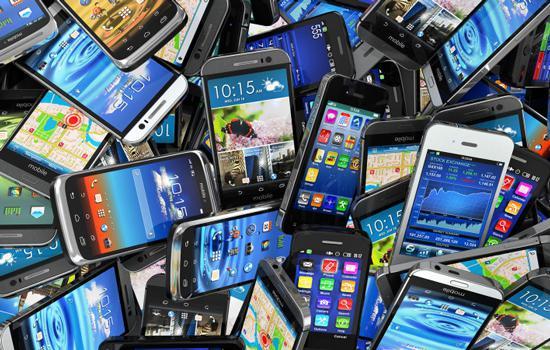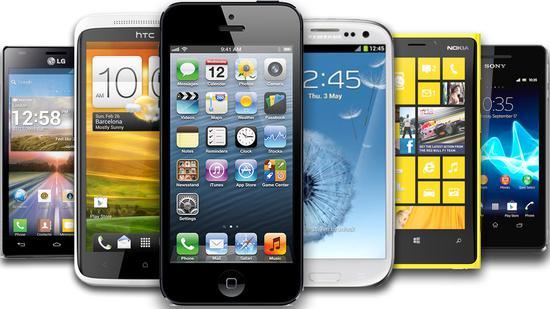The first image is the image on the left, the second image is the image on the right. Given the left and right images, does the statement "No image contains more than 9 screened devices, and one image shows multiple devices in a straight row." hold true? Answer yes or no. No. The first image is the image on the left, the second image is the image on the right. Analyze the images presented: Is the assertion "The right image contains no more than four smart phones." valid? Answer yes or no. No. 